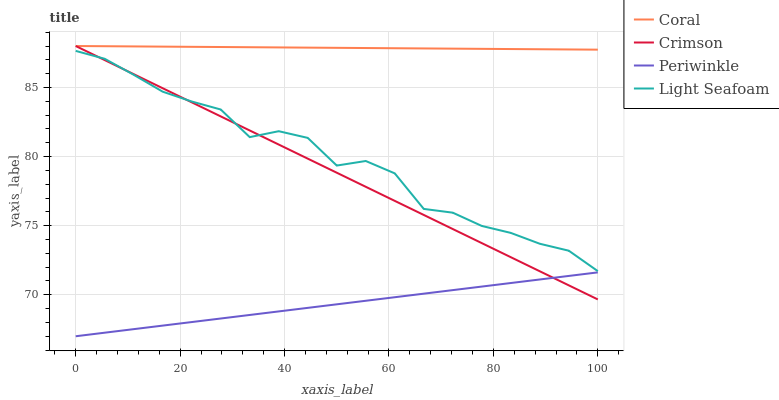Does Periwinkle have the minimum area under the curve?
Answer yes or no. Yes. Does Coral have the maximum area under the curve?
Answer yes or no. Yes. Does Light Seafoam have the minimum area under the curve?
Answer yes or no. No. Does Light Seafoam have the maximum area under the curve?
Answer yes or no. No. Is Coral the smoothest?
Answer yes or no. Yes. Is Light Seafoam the roughest?
Answer yes or no. Yes. Is Light Seafoam the smoothest?
Answer yes or no. No. Is Coral the roughest?
Answer yes or no. No. Does Light Seafoam have the lowest value?
Answer yes or no. No. Does Coral have the highest value?
Answer yes or no. Yes. Does Light Seafoam have the highest value?
Answer yes or no. No. Is Light Seafoam less than Coral?
Answer yes or no. Yes. Is Coral greater than Periwinkle?
Answer yes or no. Yes. Does Coral intersect Crimson?
Answer yes or no. Yes. Is Coral less than Crimson?
Answer yes or no. No. Is Coral greater than Crimson?
Answer yes or no. No. Does Light Seafoam intersect Coral?
Answer yes or no. No. 